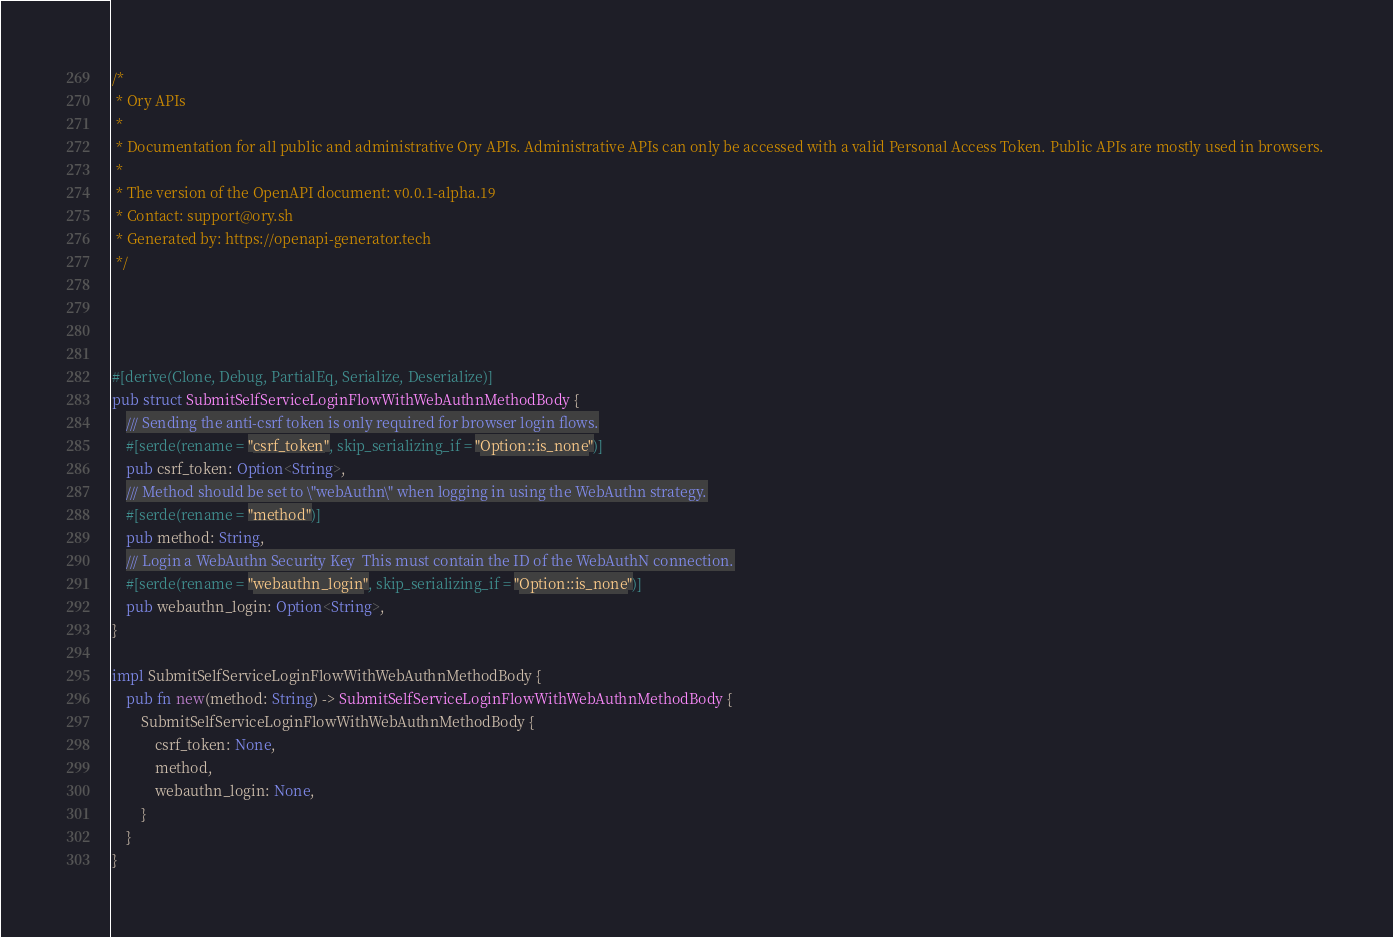Convert code to text. <code><loc_0><loc_0><loc_500><loc_500><_Rust_>/*
 * Ory APIs
 *
 * Documentation for all public and administrative Ory APIs. Administrative APIs can only be accessed with a valid Personal Access Token. Public APIs are mostly used in browsers. 
 *
 * The version of the OpenAPI document: v0.0.1-alpha.19
 * Contact: support@ory.sh
 * Generated by: https://openapi-generator.tech
 */




#[derive(Clone, Debug, PartialEq, Serialize, Deserialize)]
pub struct SubmitSelfServiceLoginFlowWithWebAuthnMethodBody {
    /// Sending the anti-csrf token is only required for browser login flows.
    #[serde(rename = "csrf_token", skip_serializing_if = "Option::is_none")]
    pub csrf_token: Option<String>,
    /// Method should be set to \"webAuthn\" when logging in using the WebAuthn strategy.
    #[serde(rename = "method")]
    pub method: String,
    /// Login a WebAuthn Security Key  This must contain the ID of the WebAuthN connection.
    #[serde(rename = "webauthn_login", skip_serializing_if = "Option::is_none")]
    pub webauthn_login: Option<String>,
}

impl SubmitSelfServiceLoginFlowWithWebAuthnMethodBody {
    pub fn new(method: String) -> SubmitSelfServiceLoginFlowWithWebAuthnMethodBody {
        SubmitSelfServiceLoginFlowWithWebAuthnMethodBody {
            csrf_token: None,
            method,
            webauthn_login: None,
        }
    }
}


</code> 